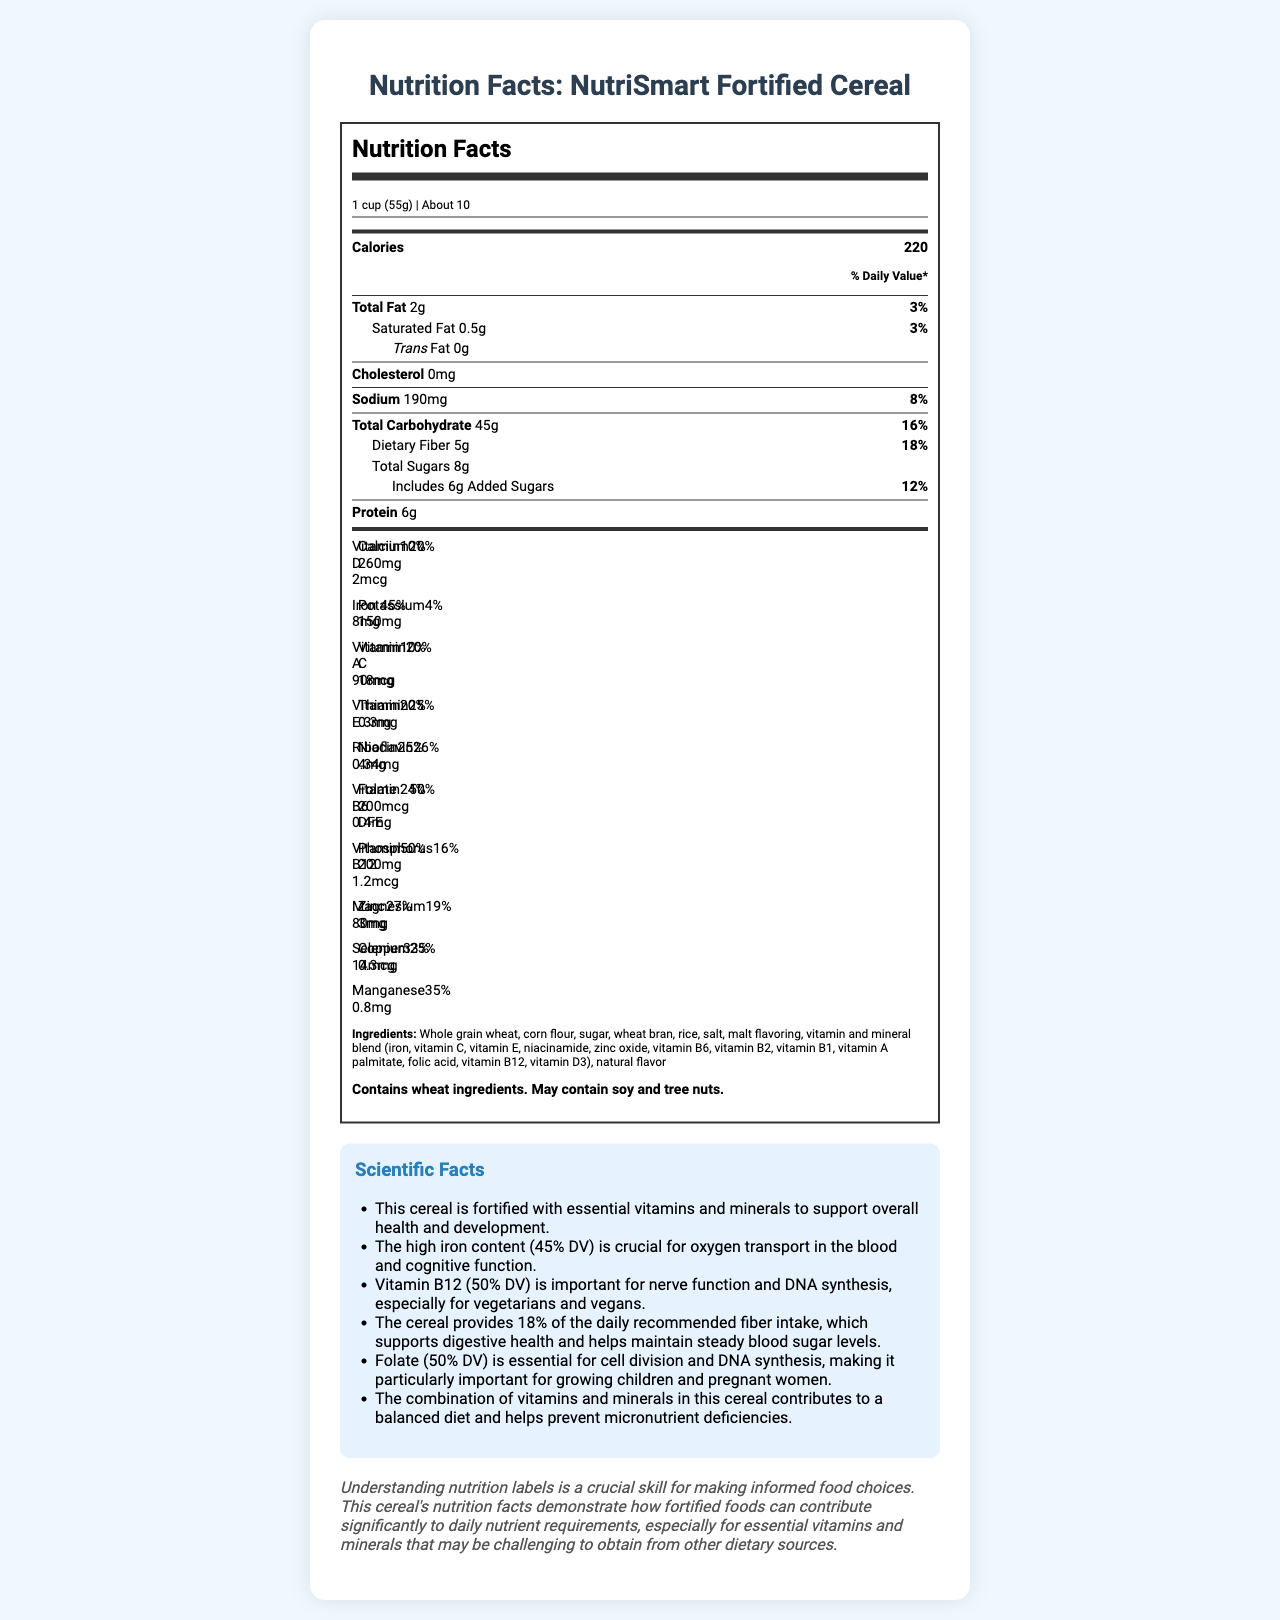what is the serving size for NutriSmart Fortified Cereal? The serving size is listed at the top of the nutrition label as "1 cup (55g)".
Answer: 1 cup (55g) How many calories are there in one serving of the cereal? The calories per serving are prominently displayed under the "Calories" section as 220.
Answer: 220 What percentage of the daily value is the cereal's dietary fiber? The daily value percentage for dietary fiber is listed as 18% next to the amount of 5g in the nutrition label.
Answer: 18% List three vitamins or minerals where the daily value percentage is 25% or more. Iron is 45%, Folate is 50%, and Vitamin B12 is 50%, as noted in the vitamins and minerals section.
Answer: Iron, Folate, Vitamin B12 What is the daily value percentage for sodium in this cereal? The daily value percentage for sodium is listed as 8% next to the amount of 190mg.
Answer: 8% What ingredient is found in the highest quantity in NutriSmart Fortified Cereal? A. Corn flour B. Whole grain wheat C. Sugar D. Rice Ingredients are listed in order of quantity, and "Whole grain wheat" is the first ingredient listed.
Answer: B How much protein does one serving of NutriSmart Fortified Cereal contain? The amount of protein is listed in the nutrition label section as 6g.
Answer: 6g Does the cereal contain any cholesterol? The label lists "Cholesterol: 0mg," indicating that it contains no cholesterol.
Answer: No What is the significance of folate for growing children and pregnant women according to the scientific facts? The scientific facts state that folate is essential for cell division and DNA synthesis, which is particularly important for growing children and pregnant women.
Answer: Essential for cell division and DNA synthesis How does the cereal aid in maintaining steady blood sugar levels? The scientific facts mention that the high fiber content helps in maintaining steady blood sugar levels.
Answer: By providing 18% of the daily recommended fiber intake How many servings per container are there? The document lists "About 10" under the servings per container section.
Answer: About 10 Which of the following vitamins does this cereal contain 50% of the daily value for? I. Vitamin D II. Folate III. Vitamin B12 IV. Vitamin A Folate and Vitamin B12, both listed as 50% DV.
Answer: II and III Which vitamin in NutriSmart Fortified Cereal is important for nerve function and DNA synthesis, especially for vegetarians and vegans? The scientific facts state that Vitamin B12 is important for nerve function and DNA synthesis, especially for vegetarians and vegans, and provides 50% DV.
Answer: Vitamin B12 List two minerals present in the cereal that support overall health and development. The scientific facts mention that the cereal is fortified with essential vitamins and minerals, including Iron (important for oxygen transport and cognitive function) and Zinc (important for overall health).
Answer: Iron and Zinc Is there any information about the cost of NutriSmart Fortified Cereal? The document does not provide any information about the cost of the cereal.
Answer: Not enough information Describe the main idea of the Nutrition Facts Label for NutriSmart Fortified Cereal. The document presents a comprehensive breakdown of the cereal's nutritional content per serving, focusing on how it contributes to daily nutrient intake. It underscores the benefits of fortified foods and encourages informed food choices through an educational note.
Answer: The Nutrition Facts Label for NutriSmart Fortified Cereal details the serving size, calorie count, and nutrient content, emphasizing its extensive fortification with essential vitamins and minerals. It highlights the cereal's contributions to daily nutritional requirements, particularly in terms of iron, fiber, folate, and Vitamin B12. Additionally, it provides scientific facts supporting the health benefits of the cereal and includes an educational note on the importance of understanding nutrition labels. 